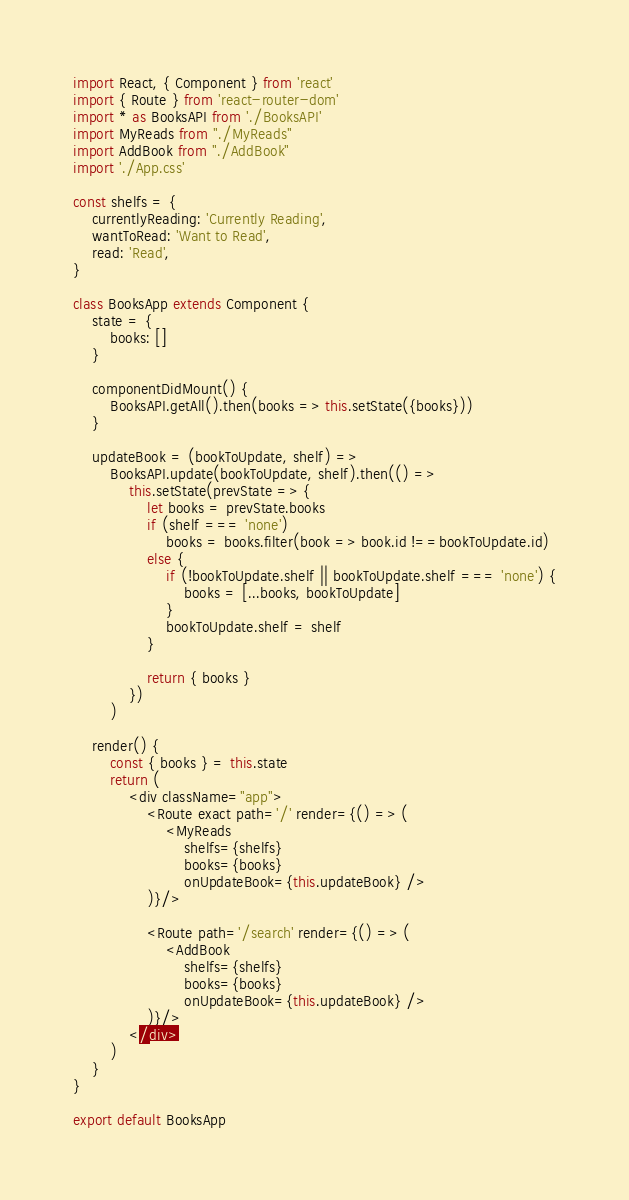<code> <loc_0><loc_0><loc_500><loc_500><_JavaScript_>import React, { Component } from 'react'
import { Route } from 'react-router-dom'
import * as BooksAPI from './BooksAPI'
import MyReads from "./MyReads"
import AddBook from "./AddBook"
import './App.css'

const shelfs = {
    currentlyReading: 'Currently Reading',
    wantToRead: 'Want to Read',
    read: 'Read',
}

class BooksApp extends Component {
    state = {
        books: []
    }

    componentDidMount() {
        BooksAPI.getAll().then(books => this.setState({books}))
    }

    updateBook = (bookToUpdate, shelf) =>
        BooksAPI.update(bookToUpdate, shelf).then(() =>
            this.setState(prevState => {
                let books = prevState.books
                if (shelf === 'none')
                    books = books.filter(book => book.id !==bookToUpdate.id)
                else {
                    if (!bookToUpdate.shelf || bookToUpdate.shelf === 'none') {
                        books = [...books, bookToUpdate]
                    }
                    bookToUpdate.shelf = shelf
                }

                return { books }
            })
        )

    render() {
        const { books } = this.state
        return (
            <div className="app">
                <Route exact path='/' render={() => (
                    <MyReads
                        shelfs={shelfs}
                        books={books}
                        onUpdateBook={this.updateBook} />
                )}/>

                <Route path='/search' render={() => (
                    <AddBook
                        shelfs={shelfs}
                        books={books}
                        onUpdateBook={this.updateBook} />
                )}/>
            </div>
        )
    }
}

export default BooksApp
</code> 